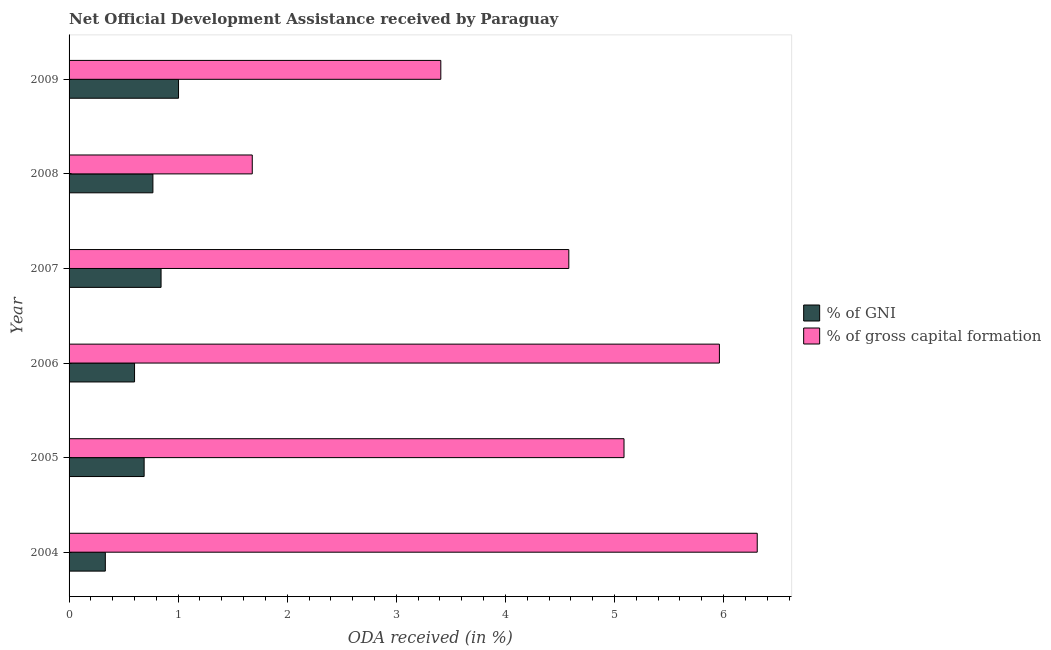How many different coloured bars are there?
Offer a very short reply. 2. Are the number of bars per tick equal to the number of legend labels?
Your answer should be compact. Yes. Are the number of bars on each tick of the Y-axis equal?
Provide a succinct answer. Yes. How many bars are there on the 5th tick from the bottom?
Make the answer very short. 2. In how many cases, is the number of bars for a given year not equal to the number of legend labels?
Provide a short and direct response. 0. What is the oda received as percentage of gni in 2006?
Keep it short and to the point. 0.6. Across all years, what is the maximum oda received as percentage of gross capital formation?
Your answer should be compact. 6.31. Across all years, what is the minimum oda received as percentage of gni?
Offer a terse response. 0.33. In which year was the oda received as percentage of gni minimum?
Give a very brief answer. 2004. What is the total oda received as percentage of gross capital formation in the graph?
Offer a terse response. 27.02. What is the difference between the oda received as percentage of gni in 2004 and that in 2005?
Give a very brief answer. -0.36. What is the difference between the oda received as percentage of gross capital formation in 2009 and the oda received as percentage of gni in 2004?
Give a very brief answer. 3.08. What is the average oda received as percentage of gross capital formation per year?
Give a very brief answer. 4.5. In the year 2008, what is the difference between the oda received as percentage of gross capital formation and oda received as percentage of gni?
Provide a succinct answer. 0.91. In how many years, is the oda received as percentage of gni greater than 5.4 %?
Provide a short and direct response. 0. What is the ratio of the oda received as percentage of gni in 2004 to that in 2008?
Offer a very short reply. 0.43. What is the difference between the highest and the second highest oda received as percentage of gni?
Your answer should be compact. 0.16. What is the difference between the highest and the lowest oda received as percentage of gni?
Give a very brief answer. 0.67. Is the sum of the oda received as percentage of gni in 2004 and 2007 greater than the maximum oda received as percentage of gross capital formation across all years?
Your response must be concise. No. What does the 1st bar from the top in 2008 represents?
Your answer should be very brief. % of gross capital formation. What does the 2nd bar from the bottom in 2008 represents?
Your answer should be compact. % of gross capital formation. Are all the bars in the graph horizontal?
Offer a very short reply. Yes. Does the graph contain grids?
Give a very brief answer. No. How are the legend labels stacked?
Provide a short and direct response. Vertical. What is the title of the graph?
Offer a very short reply. Net Official Development Assistance received by Paraguay. Does "Ages 15-24" appear as one of the legend labels in the graph?
Provide a succinct answer. No. What is the label or title of the X-axis?
Your response must be concise. ODA received (in %). What is the ODA received (in %) in % of GNI in 2004?
Give a very brief answer. 0.33. What is the ODA received (in %) of % of gross capital formation in 2004?
Offer a very short reply. 6.31. What is the ODA received (in %) in % of GNI in 2005?
Give a very brief answer. 0.69. What is the ODA received (in %) in % of gross capital formation in 2005?
Offer a very short reply. 5.09. What is the ODA received (in %) in % of GNI in 2006?
Your response must be concise. 0.6. What is the ODA received (in %) in % of gross capital formation in 2006?
Offer a terse response. 5.96. What is the ODA received (in %) of % of GNI in 2007?
Ensure brevity in your answer.  0.84. What is the ODA received (in %) in % of gross capital formation in 2007?
Make the answer very short. 4.58. What is the ODA received (in %) of % of GNI in 2008?
Your answer should be very brief. 0.77. What is the ODA received (in %) of % of gross capital formation in 2008?
Make the answer very short. 1.68. What is the ODA received (in %) of % of GNI in 2009?
Make the answer very short. 1. What is the ODA received (in %) in % of gross capital formation in 2009?
Offer a terse response. 3.41. Across all years, what is the maximum ODA received (in %) of % of GNI?
Provide a succinct answer. 1. Across all years, what is the maximum ODA received (in %) of % of gross capital formation?
Provide a succinct answer. 6.31. Across all years, what is the minimum ODA received (in %) in % of GNI?
Ensure brevity in your answer.  0.33. Across all years, what is the minimum ODA received (in %) in % of gross capital formation?
Provide a succinct answer. 1.68. What is the total ODA received (in %) in % of GNI in the graph?
Give a very brief answer. 4.24. What is the total ODA received (in %) in % of gross capital formation in the graph?
Your answer should be very brief. 27.02. What is the difference between the ODA received (in %) in % of GNI in 2004 and that in 2005?
Your answer should be very brief. -0.36. What is the difference between the ODA received (in %) of % of gross capital formation in 2004 and that in 2005?
Give a very brief answer. 1.22. What is the difference between the ODA received (in %) of % of GNI in 2004 and that in 2006?
Make the answer very short. -0.27. What is the difference between the ODA received (in %) of % of gross capital formation in 2004 and that in 2006?
Provide a succinct answer. 0.35. What is the difference between the ODA received (in %) in % of GNI in 2004 and that in 2007?
Provide a short and direct response. -0.51. What is the difference between the ODA received (in %) in % of gross capital formation in 2004 and that in 2007?
Provide a short and direct response. 1.73. What is the difference between the ODA received (in %) in % of GNI in 2004 and that in 2008?
Ensure brevity in your answer.  -0.44. What is the difference between the ODA received (in %) in % of gross capital formation in 2004 and that in 2008?
Give a very brief answer. 4.63. What is the difference between the ODA received (in %) in % of GNI in 2004 and that in 2009?
Keep it short and to the point. -0.67. What is the difference between the ODA received (in %) in % of gross capital formation in 2004 and that in 2009?
Give a very brief answer. 2.9. What is the difference between the ODA received (in %) in % of GNI in 2005 and that in 2006?
Give a very brief answer. 0.09. What is the difference between the ODA received (in %) in % of gross capital formation in 2005 and that in 2006?
Provide a succinct answer. -0.87. What is the difference between the ODA received (in %) of % of GNI in 2005 and that in 2007?
Your answer should be very brief. -0.16. What is the difference between the ODA received (in %) in % of gross capital formation in 2005 and that in 2007?
Give a very brief answer. 0.51. What is the difference between the ODA received (in %) in % of GNI in 2005 and that in 2008?
Offer a very short reply. -0.08. What is the difference between the ODA received (in %) in % of gross capital formation in 2005 and that in 2008?
Your answer should be compact. 3.41. What is the difference between the ODA received (in %) of % of GNI in 2005 and that in 2009?
Your response must be concise. -0.32. What is the difference between the ODA received (in %) of % of gross capital formation in 2005 and that in 2009?
Your answer should be very brief. 1.68. What is the difference between the ODA received (in %) in % of GNI in 2006 and that in 2007?
Ensure brevity in your answer.  -0.24. What is the difference between the ODA received (in %) in % of gross capital formation in 2006 and that in 2007?
Offer a terse response. 1.38. What is the difference between the ODA received (in %) in % of GNI in 2006 and that in 2008?
Offer a very short reply. -0.17. What is the difference between the ODA received (in %) in % of gross capital formation in 2006 and that in 2008?
Your answer should be compact. 4.28. What is the difference between the ODA received (in %) of % of GNI in 2006 and that in 2009?
Provide a short and direct response. -0.4. What is the difference between the ODA received (in %) in % of gross capital formation in 2006 and that in 2009?
Your answer should be compact. 2.55. What is the difference between the ODA received (in %) in % of GNI in 2007 and that in 2008?
Ensure brevity in your answer.  0.07. What is the difference between the ODA received (in %) of % of gross capital formation in 2007 and that in 2008?
Ensure brevity in your answer.  2.9. What is the difference between the ODA received (in %) of % of GNI in 2007 and that in 2009?
Offer a very short reply. -0.16. What is the difference between the ODA received (in %) in % of gross capital formation in 2007 and that in 2009?
Your answer should be compact. 1.17. What is the difference between the ODA received (in %) of % of GNI in 2008 and that in 2009?
Your response must be concise. -0.23. What is the difference between the ODA received (in %) in % of gross capital formation in 2008 and that in 2009?
Ensure brevity in your answer.  -1.73. What is the difference between the ODA received (in %) of % of GNI in 2004 and the ODA received (in %) of % of gross capital formation in 2005?
Your answer should be compact. -4.75. What is the difference between the ODA received (in %) of % of GNI in 2004 and the ODA received (in %) of % of gross capital formation in 2006?
Provide a succinct answer. -5.63. What is the difference between the ODA received (in %) in % of GNI in 2004 and the ODA received (in %) in % of gross capital formation in 2007?
Provide a succinct answer. -4.25. What is the difference between the ODA received (in %) in % of GNI in 2004 and the ODA received (in %) in % of gross capital formation in 2008?
Provide a short and direct response. -1.35. What is the difference between the ODA received (in %) of % of GNI in 2004 and the ODA received (in %) of % of gross capital formation in 2009?
Offer a terse response. -3.08. What is the difference between the ODA received (in %) of % of GNI in 2005 and the ODA received (in %) of % of gross capital formation in 2006?
Give a very brief answer. -5.27. What is the difference between the ODA received (in %) in % of GNI in 2005 and the ODA received (in %) in % of gross capital formation in 2007?
Offer a terse response. -3.89. What is the difference between the ODA received (in %) of % of GNI in 2005 and the ODA received (in %) of % of gross capital formation in 2008?
Offer a terse response. -0.99. What is the difference between the ODA received (in %) of % of GNI in 2005 and the ODA received (in %) of % of gross capital formation in 2009?
Ensure brevity in your answer.  -2.72. What is the difference between the ODA received (in %) of % of GNI in 2006 and the ODA received (in %) of % of gross capital formation in 2007?
Your answer should be compact. -3.98. What is the difference between the ODA received (in %) of % of GNI in 2006 and the ODA received (in %) of % of gross capital formation in 2008?
Offer a very short reply. -1.08. What is the difference between the ODA received (in %) in % of GNI in 2006 and the ODA received (in %) in % of gross capital formation in 2009?
Offer a terse response. -2.81. What is the difference between the ODA received (in %) of % of GNI in 2007 and the ODA received (in %) of % of gross capital formation in 2008?
Give a very brief answer. -0.84. What is the difference between the ODA received (in %) in % of GNI in 2007 and the ODA received (in %) in % of gross capital formation in 2009?
Keep it short and to the point. -2.56. What is the difference between the ODA received (in %) in % of GNI in 2008 and the ODA received (in %) in % of gross capital formation in 2009?
Your answer should be compact. -2.64. What is the average ODA received (in %) in % of GNI per year?
Offer a very short reply. 0.71. What is the average ODA received (in %) of % of gross capital formation per year?
Offer a very short reply. 4.5. In the year 2004, what is the difference between the ODA received (in %) of % of GNI and ODA received (in %) of % of gross capital formation?
Your answer should be compact. -5.98. In the year 2005, what is the difference between the ODA received (in %) of % of GNI and ODA received (in %) of % of gross capital formation?
Your answer should be compact. -4.4. In the year 2006, what is the difference between the ODA received (in %) of % of GNI and ODA received (in %) of % of gross capital formation?
Your response must be concise. -5.36. In the year 2007, what is the difference between the ODA received (in %) of % of GNI and ODA received (in %) of % of gross capital formation?
Your response must be concise. -3.74. In the year 2008, what is the difference between the ODA received (in %) of % of GNI and ODA received (in %) of % of gross capital formation?
Offer a very short reply. -0.91. In the year 2009, what is the difference between the ODA received (in %) in % of GNI and ODA received (in %) in % of gross capital formation?
Give a very brief answer. -2.4. What is the ratio of the ODA received (in %) of % of GNI in 2004 to that in 2005?
Your response must be concise. 0.48. What is the ratio of the ODA received (in %) of % of gross capital formation in 2004 to that in 2005?
Your answer should be compact. 1.24. What is the ratio of the ODA received (in %) of % of GNI in 2004 to that in 2006?
Offer a terse response. 0.55. What is the ratio of the ODA received (in %) of % of gross capital formation in 2004 to that in 2006?
Keep it short and to the point. 1.06. What is the ratio of the ODA received (in %) in % of GNI in 2004 to that in 2007?
Offer a terse response. 0.39. What is the ratio of the ODA received (in %) in % of gross capital formation in 2004 to that in 2007?
Ensure brevity in your answer.  1.38. What is the ratio of the ODA received (in %) in % of GNI in 2004 to that in 2008?
Your answer should be compact. 0.43. What is the ratio of the ODA received (in %) in % of gross capital formation in 2004 to that in 2008?
Your answer should be very brief. 3.76. What is the ratio of the ODA received (in %) of % of GNI in 2004 to that in 2009?
Provide a short and direct response. 0.33. What is the ratio of the ODA received (in %) in % of gross capital formation in 2004 to that in 2009?
Provide a succinct answer. 1.85. What is the ratio of the ODA received (in %) of % of GNI in 2005 to that in 2006?
Ensure brevity in your answer.  1.15. What is the ratio of the ODA received (in %) in % of gross capital formation in 2005 to that in 2006?
Offer a terse response. 0.85. What is the ratio of the ODA received (in %) in % of GNI in 2005 to that in 2007?
Your response must be concise. 0.82. What is the ratio of the ODA received (in %) in % of gross capital formation in 2005 to that in 2007?
Your response must be concise. 1.11. What is the ratio of the ODA received (in %) of % of GNI in 2005 to that in 2008?
Your response must be concise. 0.9. What is the ratio of the ODA received (in %) of % of gross capital formation in 2005 to that in 2008?
Provide a succinct answer. 3.03. What is the ratio of the ODA received (in %) of % of GNI in 2005 to that in 2009?
Ensure brevity in your answer.  0.69. What is the ratio of the ODA received (in %) in % of gross capital formation in 2005 to that in 2009?
Offer a terse response. 1.49. What is the ratio of the ODA received (in %) of % of GNI in 2006 to that in 2007?
Give a very brief answer. 0.71. What is the ratio of the ODA received (in %) in % of gross capital formation in 2006 to that in 2007?
Offer a very short reply. 1.3. What is the ratio of the ODA received (in %) in % of GNI in 2006 to that in 2008?
Offer a terse response. 0.78. What is the ratio of the ODA received (in %) in % of gross capital formation in 2006 to that in 2008?
Offer a terse response. 3.55. What is the ratio of the ODA received (in %) of % of GNI in 2006 to that in 2009?
Your answer should be compact. 0.6. What is the ratio of the ODA received (in %) of % of gross capital formation in 2006 to that in 2009?
Make the answer very short. 1.75. What is the ratio of the ODA received (in %) in % of GNI in 2007 to that in 2008?
Ensure brevity in your answer.  1.1. What is the ratio of the ODA received (in %) of % of gross capital formation in 2007 to that in 2008?
Provide a succinct answer. 2.73. What is the ratio of the ODA received (in %) of % of GNI in 2007 to that in 2009?
Keep it short and to the point. 0.84. What is the ratio of the ODA received (in %) in % of gross capital formation in 2007 to that in 2009?
Make the answer very short. 1.34. What is the ratio of the ODA received (in %) in % of GNI in 2008 to that in 2009?
Your answer should be very brief. 0.77. What is the ratio of the ODA received (in %) in % of gross capital formation in 2008 to that in 2009?
Provide a short and direct response. 0.49. What is the difference between the highest and the second highest ODA received (in %) in % of GNI?
Ensure brevity in your answer.  0.16. What is the difference between the highest and the second highest ODA received (in %) in % of gross capital formation?
Keep it short and to the point. 0.35. What is the difference between the highest and the lowest ODA received (in %) of % of GNI?
Your response must be concise. 0.67. What is the difference between the highest and the lowest ODA received (in %) of % of gross capital formation?
Offer a terse response. 4.63. 